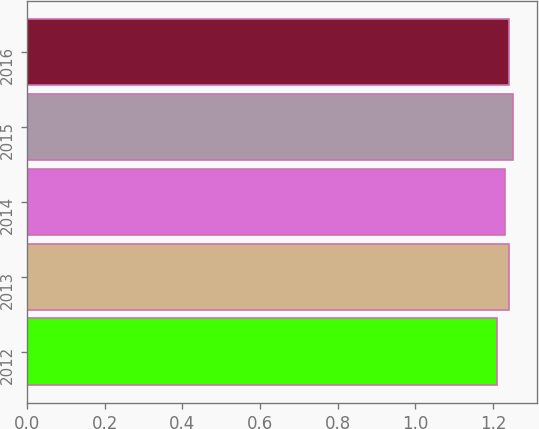<chart> <loc_0><loc_0><loc_500><loc_500><bar_chart><fcel>2012<fcel>2013<fcel>2014<fcel>2015<fcel>2016<nl><fcel>1.21<fcel>1.24<fcel>1.23<fcel>1.25<fcel>1.24<nl></chart> 